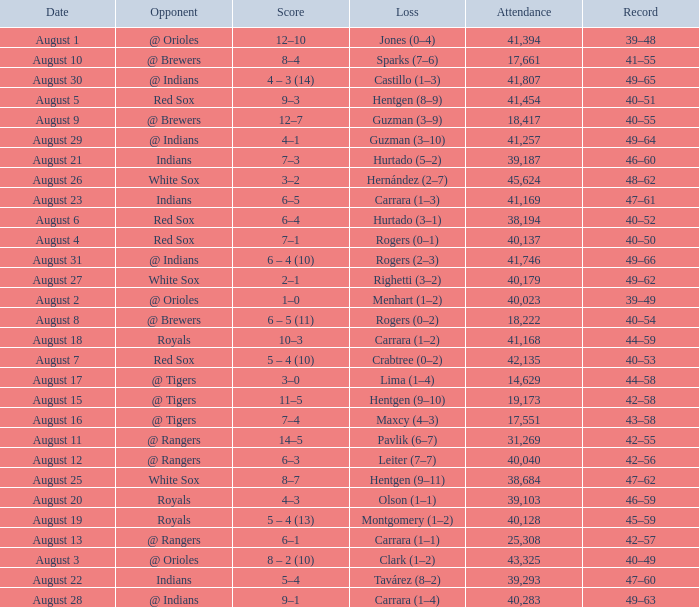Who did they play on August 12? @ Rangers. 